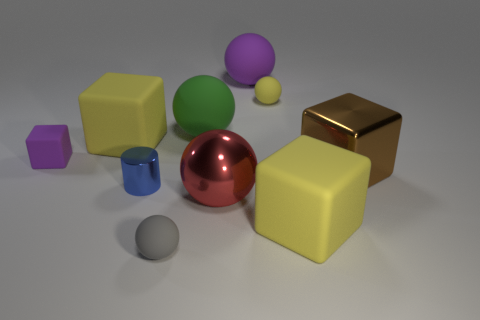Do the large rubber object that is on the left side of the gray rubber sphere and the big matte object that is in front of the brown metal object have the same color?
Your answer should be very brief. Yes. There is a yellow ball that is the same material as the small gray thing; what size is it?
Keep it short and to the point. Small. What shape is the purple rubber thing that is to the right of the small gray rubber thing?
Offer a terse response. Sphere. There is a purple matte thing that is the same shape as the brown metallic object; what size is it?
Ensure brevity in your answer.  Small. There is a large metallic thing to the left of the big cube in front of the blue thing; what number of rubber objects are in front of it?
Your answer should be very brief. 2. Are there the same number of large purple matte balls that are to the right of the brown cube and small red metallic spheres?
Offer a terse response. Yes. How many blocks are purple objects or gray objects?
Your response must be concise. 1. Are there the same number of big green rubber balls on the right side of the big purple sphere and purple matte things that are in front of the gray matte ball?
Make the answer very short. Yes. The metal sphere has what color?
Your response must be concise. Red. How many things are matte balls that are on the left side of the large green rubber ball or gray matte cylinders?
Your answer should be compact. 1. 